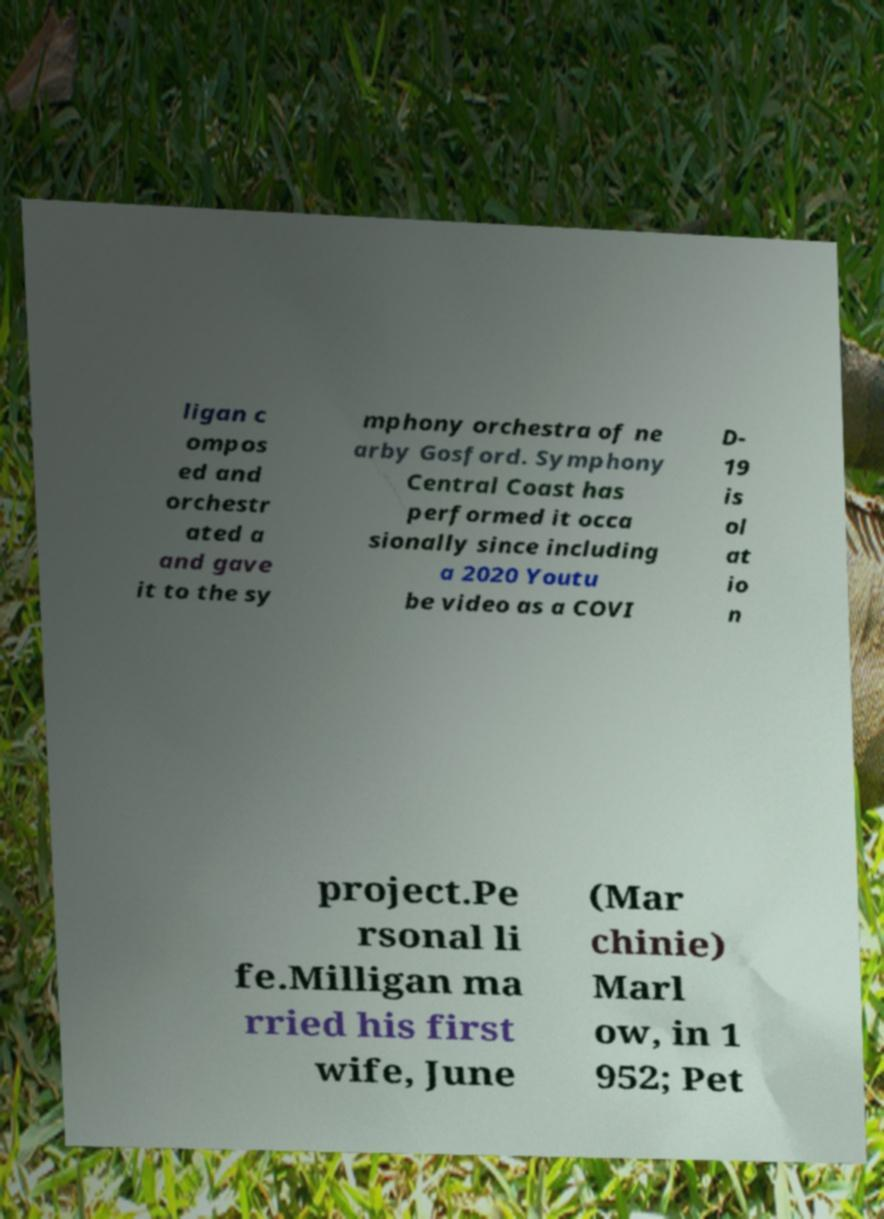Please read and relay the text visible in this image. What does it say? ligan c ompos ed and orchestr ated a and gave it to the sy mphony orchestra of ne arby Gosford. Symphony Central Coast has performed it occa sionally since including a 2020 Youtu be video as a COVI D- 19 is ol at io n project.Pe rsonal li fe.Milligan ma rried his first wife, June (Mar chinie) Marl ow, in 1 952; Pet 